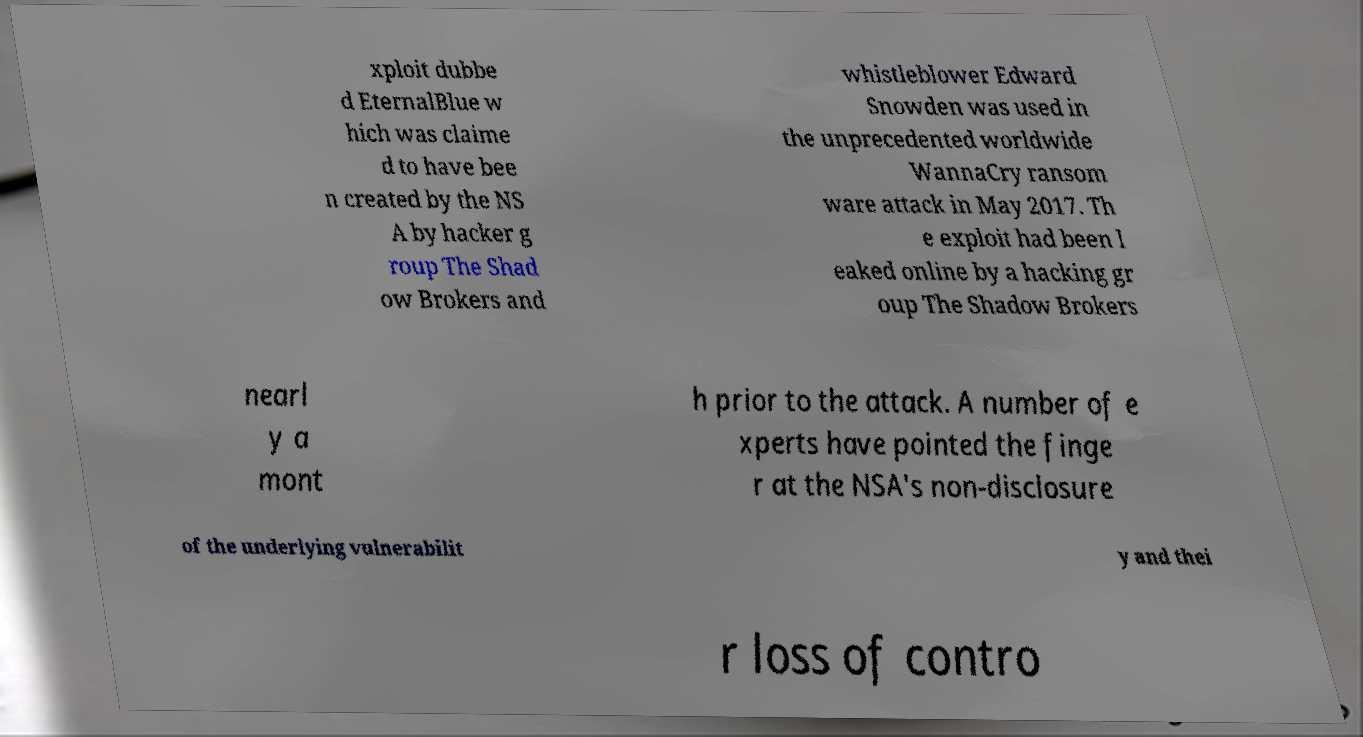For documentation purposes, I need the text within this image transcribed. Could you provide that? xploit dubbe d EternalBlue w hich was claime d to have bee n created by the NS A by hacker g roup The Shad ow Brokers and whistleblower Edward Snowden was used in the unprecedented worldwide WannaCry ransom ware attack in May 2017. Th e exploit had been l eaked online by a hacking gr oup The Shadow Brokers nearl y a mont h prior to the attack. A number of e xperts have pointed the finge r at the NSA's non-disclosure of the underlying vulnerabilit y and thei r loss of contro 